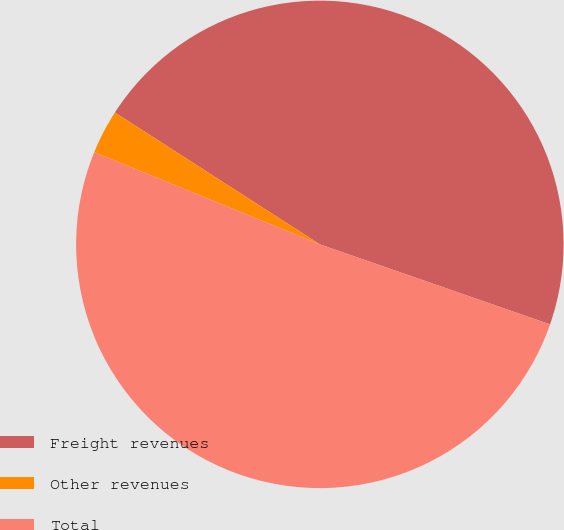<chart> <loc_0><loc_0><loc_500><loc_500><pie_chart><fcel>Freight revenues<fcel>Other revenues<fcel>Total<nl><fcel>46.23%<fcel>2.93%<fcel>50.85%<nl></chart> 